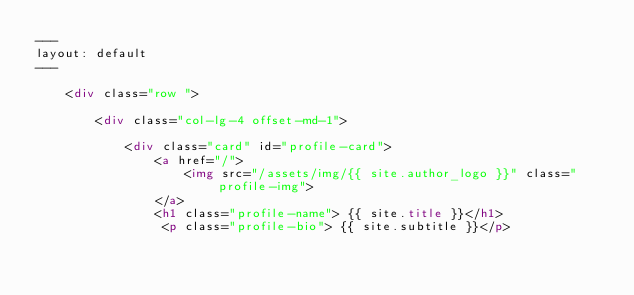<code> <loc_0><loc_0><loc_500><loc_500><_HTML_>---
layout: default
---

    <div class="row ">

        <div class="col-lg-4 offset-md-1">

            <div class="card" id="profile-card">
                <a href="/">
                    <img src="/assets/img/{{ site.author_logo }}" class="profile-img">
                </a>
                <h1 class="profile-name"> {{ site.title }}</h1>
                 <p class="profile-bio"> {{ site.subtitle }}</p></code> 